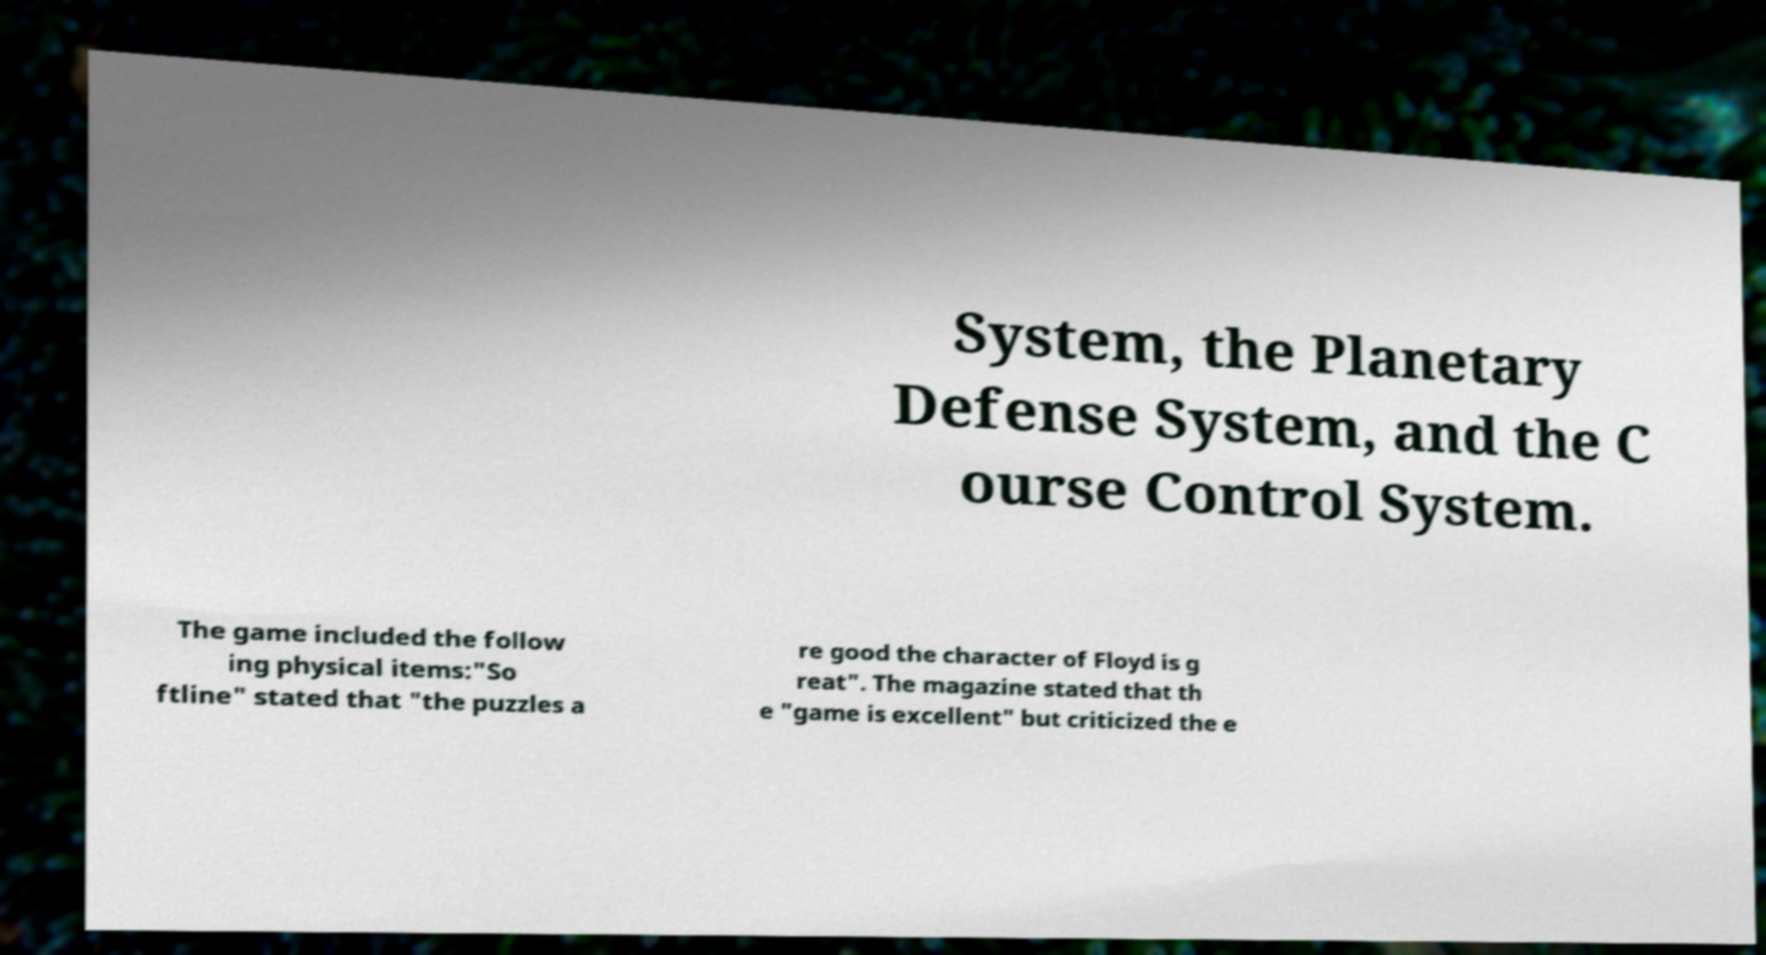Can you read and provide the text displayed in the image?This photo seems to have some interesting text. Can you extract and type it out for me? System, the Planetary Defense System, and the C ourse Control System. The game included the follow ing physical items:"So ftline" stated that "the puzzles a re good the character of Floyd is g reat". The magazine stated that th e "game is excellent" but criticized the e 